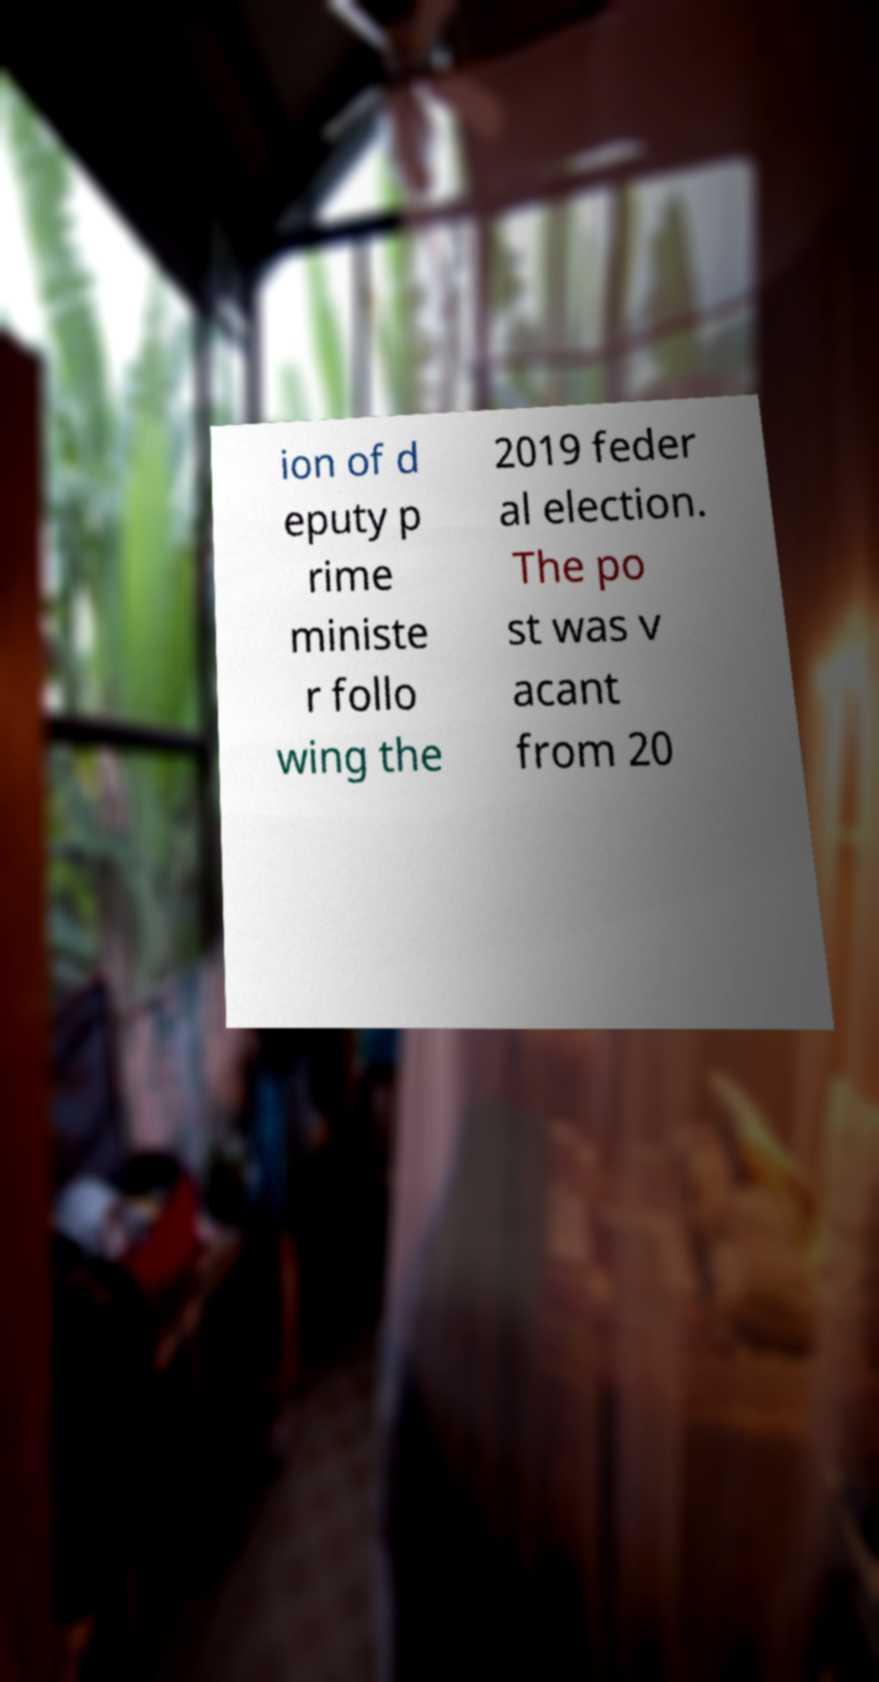I need the written content from this picture converted into text. Can you do that? ion of d eputy p rime ministe r follo wing the 2019 feder al election. The po st was v acant from 20 